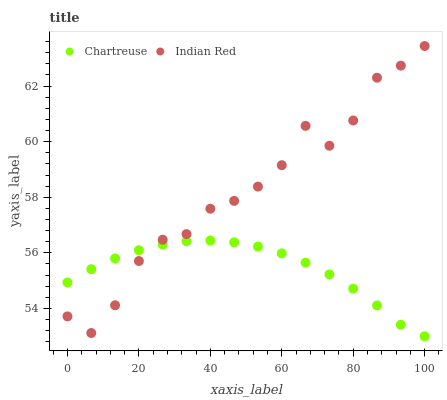Does Chartreuse have the minimum area under the curve?
Answer yes or no. Yes. Does Indian Red have the maximum area under the curve?
Answer yes or no. Yes. Does Indian Red have the minimum area under the curve?
Answer yes or no. No. Is Chartreuse the smoothest?
Answer yes or no. Yes. Is Indian Red the roughest?
Answer yes or no. Yes. Is Indian Red the smoothest?
Answer yes or no. No. Does Chartreuse have the lowest value?
Answer yes or no. Yes. Does Indian Red have the lowest value?
Answer yes or no. No. Does Indian Red have the highest value?
Answer yes or no. Yes. Does Chartreuse intersect Indian Red?
Answer yes or no. Yes. Is Chartreuse less than Indian Red?
Answer yes or no. No. Is Chartreuse greater than Indian Red?
Answer yes or no. No. 